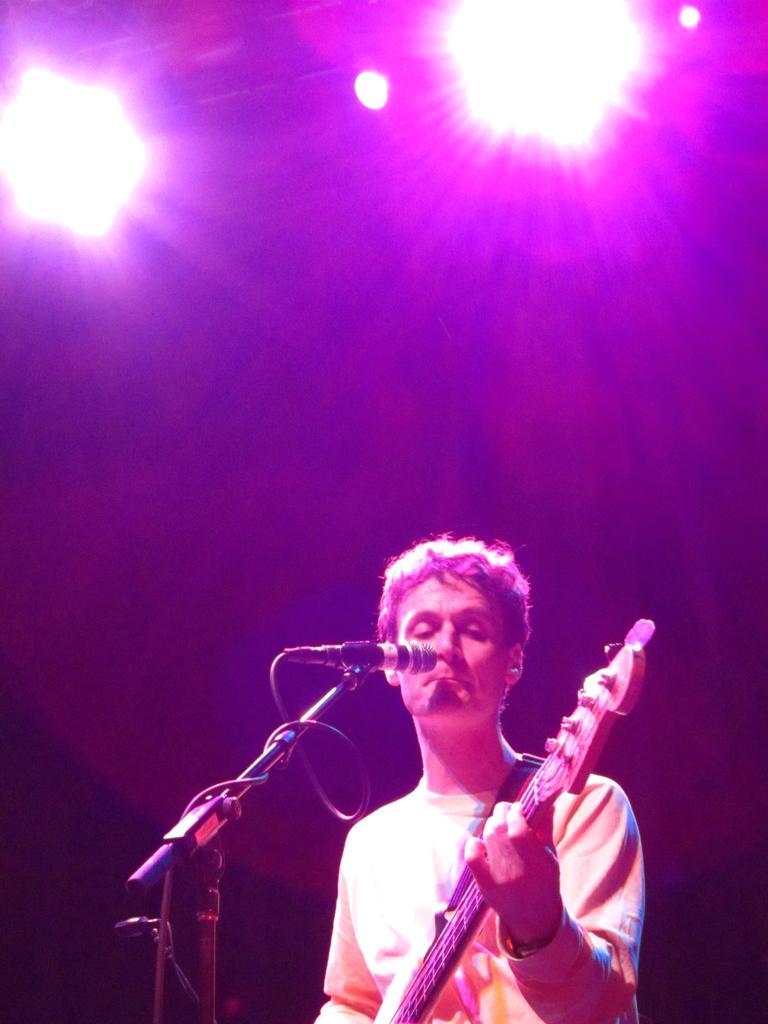Could you give a brief overview of what you see in this image? In this image I can see person holding guitar. There is a mic and a stand. 